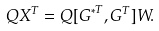<formula> <loc_0><loc_0><loc_500><loc_500>Q X ^ { T } = Q [ { G ^ { * } } ^ { T } , G ^ { T } ] W .</formula> 